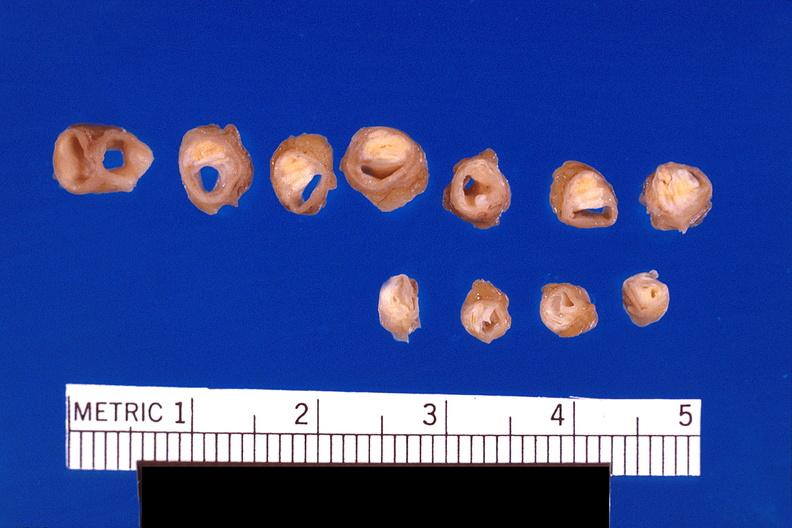s vasculature present?
Answer the question using a single word or phrase. Yes 